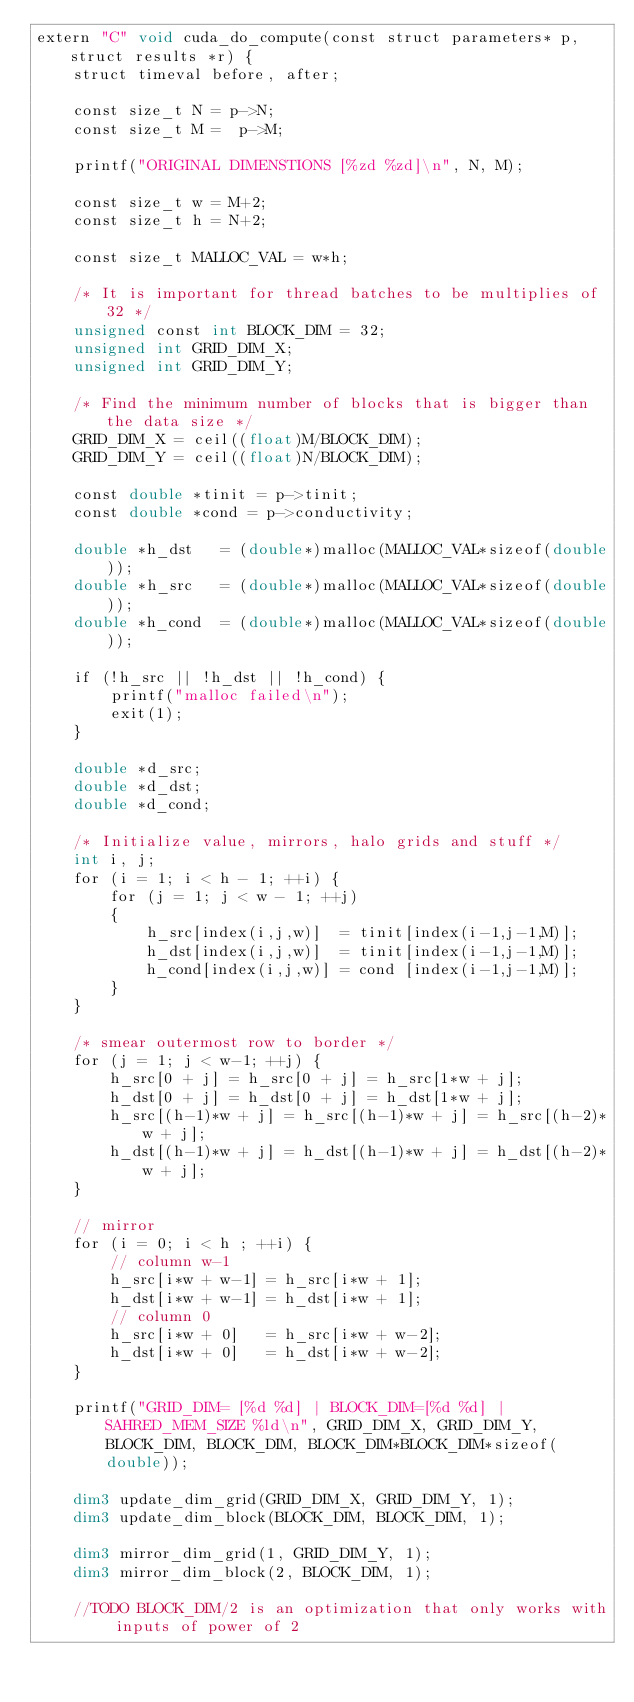Convert code to text. <code><loc_0><loc_0><loc_500><loc_500><_Cuda_>extern "C" void cuda_do_compute(const struct parameters* p, struct results *r) {
    struct timeval before, after;

    const size_t N = p->N; 
    const size_t M =  p->M; 

    printf("ORIGINAL DIMENSTIONS [%zd %zd]\n", N, M); 

    const size_t w = M+2; 
    const size_t h = N+2; 

    const size_t MALLOC_VAL = w*h; 

    /* It is important for thread batches to be multiplies of 32 */
    unsigned const int BLOCK_DIM = 32; 
    unsigned int GRID_DIM_X; 
    unsigned int GRID_DIM_Y;

    /* Find the minimum number of blocks that is bigger than the data size */
    GRID_DIM_X = ceil((float)M/BLOCK_DIM); 
    GRID_DIM_Y = ceil((float)N/BLOCK_DIM);  

    const double *tinit = p->tinit; 
    const double *cond = p->conductivity;

    double *h_dst   = (double*)malloc(MALLOC_VAL*sizeof(double)); 
    double *h_src   = (double*)malloc(MALLOC_VAL*sizeof(double)); 
    double *h_cond  = (double*)malloc(MALLOC_VAL*sizeof(double)); 

    if (!h_src || !h_dst || !h_cond) {
        printf("malloc failed\n");
        exit(1);
    }

    double *d_src;
    double *d_dst;  
    double *d_cond; 

    /* Initialize value, mirrors, halo grids and stuff */
    int i, j;
    for (i = 1; i < h - 1; ++i) {
        for (j = 1; j < w - 1; ++j)
        {
            h_src[index(i,j,w)]  = tinit[index(i-1,j-1,M)];
            h_dst[index(i,j,w)]  = tinit[index(i-1,j-1,M)];
            h_cond[index(i,j,w)] = cond [index(i-1,j-1,M)];
        }
    }

    /* smear outermost row to border */
    for (j = 1; j < w-1; ++j) {
        h_src[0 + j] = h_src[0 + j] = h_src[1*w + j];
        h_dst[0 + j] = h_dst[0 + j] = h_dst[1*w + j];
        h_src[(h-1)*w + j] = h_src[(h-1)*w + j] = h_src[(h-2)*w + j];
        h_dst[(h-1)*w + j] = h_dst[(h-1)*w + j] = h_dst[(h-2)*w + j];
    }

    // mirror 
    for (i = 0; i < h ; ++i) {
        // column w-1 
        h_src[i*w + w-1] = h_src[i*w + 1];
        h_dst[i*w + w-1] = h_dst[i*w + 1];
        // column 0 
        h_src[i*w + 0]   = h_src[i*w + w-2];
        h_dst[i*w + 0]   = h_dst[i*w + w-2];
    }
    
    printf("GRID_DIM= [%d %d] | BLOCK_DIM=[%d %d] | SAHRED_MEM_SIZE %ld\n", GRID_DIM_X, GRID_DIM_Y, BLOCK_DIM, BLOCK_DIM, BLOCK_DIM*BLOCK_DIM*sizeof(double));

    dim3 update_dim_grid(GRID_DIM_X, GRID_DIM_Y, 1); 
    dim3 update_dim_block(BLOCK_DIM, BLOCK_DIM, 1); 

    dim3 mirror_dim_grid(1, GRID_DIM_Y, 1); 
    dim3 mirror_dim_block(2, BLOCK_DIM, 1); 

    //TODO BLOCK_DIM/2 is an optimization that only works with inputs of power of 2</code> 